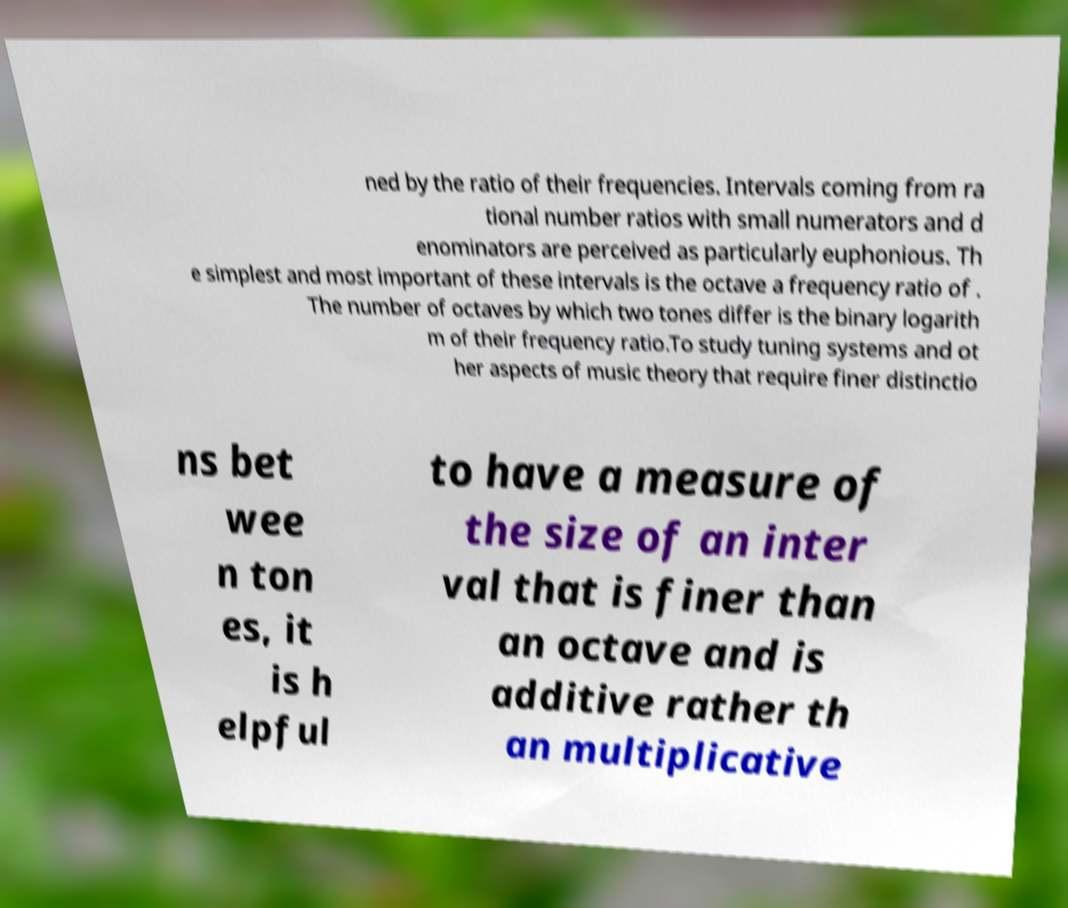I need the written content from this picture converted into text. Can you do that? ned by the ratio of their frequencies. Intervals coming from ra tional number ratios with small numerators and d enominators are perceived as particularly euphonious. Th e simplest and most important of these intervals is the octave a frequency ratio of . The number of octaves by which two tones differ is the binary logarith m of their frequency ratio.To study tuning systems and ot her aspects of music theory that require finer distinctio ns bet wee n ton es, it is h elpful to have a measure of the size of an inter val that is finer than an octave and is additive rather th an multiplicative 